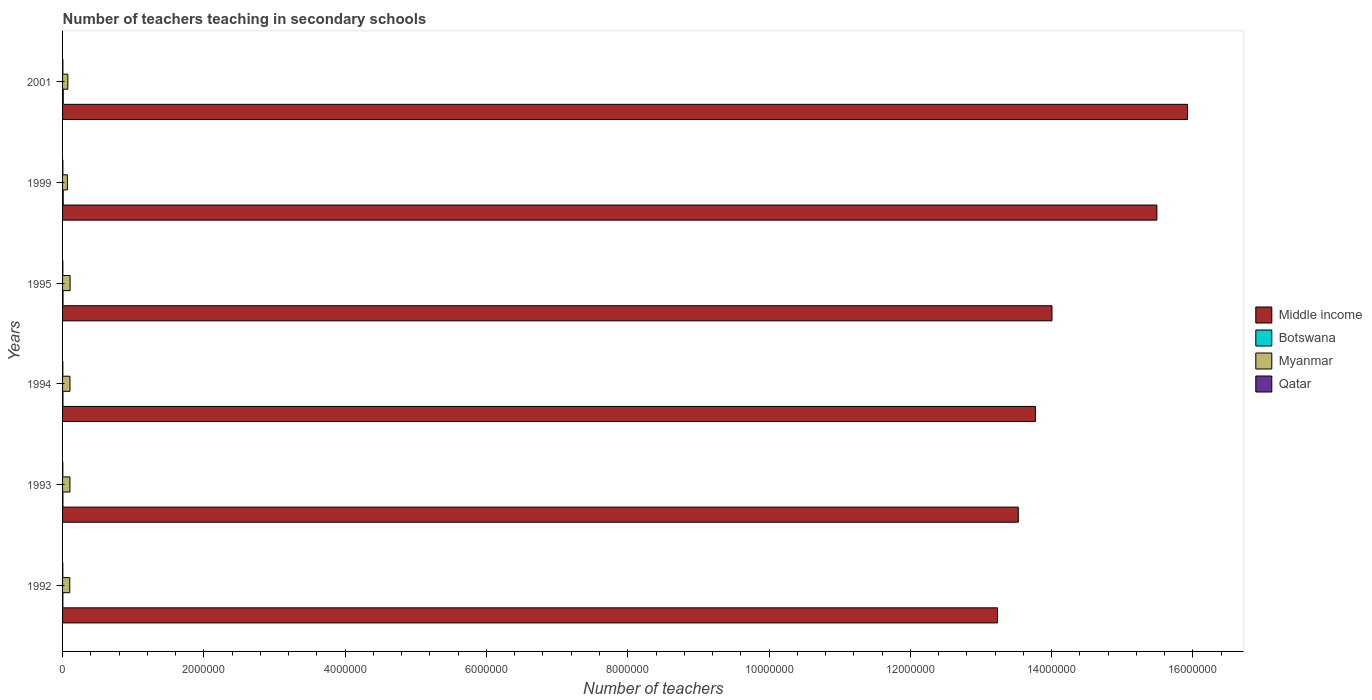Are the number of bars per tick equal to the number of legend labels?
Provide a succinct answer. Yes. Are the number of bars on each tick of the Y-axis equal?
Offer a very short reply. Yes. How many bars are there on the 1st tick from the bottom?
Keep it short and to the point. 4. What is the number of teachers teaching in secondary schools in Myanmar in 1995?
Your response must be concise. 1.07e+05. Across all years, what is the maximum number of teachers teaching in secondary schools in Qatar?
Make the answer very short. 4516. Across all years, what is the minimum number of teachers teaching in secondary schools in Qatar?
Your answer should be compact. 3724. What is the total number of teachers teaching in secondary schools in Middle income in the graph?
Your answer should be compact. 8.60e+07. What is the difference between the number of teachers teaching in secondary schools in Qatar in 1995 and that in 2001?
Keep it short and to the point. -658. What is the difference between the number of teachers teaching in secondary schools in Qatar in 1992 and the number of teachers teaching in secondary schools in Middle income in 1995?
Your answer should be compact. -1.40e+07. What is the average number of teachers teaching in secondary schools in Middle income per year?
Provide a succinct answer. 1.43e+07. In the year 1999, what is the difference between the number of teachers teaching in secondary schools in Middle income and number of teachers teaching in secondary schools in Qatar?
Your answer should be very brief. 1.55e+07. In how many years, is the number of teachers teaching in secondary schools in Myanmar greater than 14000000 ?
Your response must be concise. 0. What is the ratio of the number of teachers teaching in secondary schools in Myanmar in 1995 to that in 2001?
Make the answer very short. 1.43. Is the difference between the number of teachers teaching in secondary schools in Middle income in 1992 and 1999 greater than the difference between the number of teachers teaching in secondary schools in Qatar in 1992 and 1999?
Keep it short and to the point. No. What is the difference between the highest and the second highest number of teachers teaching in secondary schools in Qatar?
Keep it short and to the point. 146. What is the difference between the highest and the lowest number of teachers teaching in secondary schools in Middle income?
Your response must be concise. 2.69e+06. In how many years, is the number of teachers teaching in secondary schools in Middle income greater than the average number of teachers teaching in secondary schools in Middle income taken over all years?
Give a very brief answer. 2. Is it the case that in every year, the sum of the number of teachers teaching in secondary schools in Botswana and number of teachers teaching in secondary schools in Myanmar is greater than the sum of number of teachers teaching in secondary schools in Middle income and number of teachers teaching in secondary schools in Qatar?
Make the answer very short. Yes. What does the 1st bar from the top in 1994 represents?
Offer a very short reply. Qatar. What does the 4th bar from the bottom in 1995 represents?
Provide a short and direct response. Qatar. Is it the case that in every year, the sum of the number of teachers teaching in secondary schools in Myanmar and number of teachers teaching in secondary schools in Botswana is greater than the number of teachers teaching in secondary schools in Qatar?
Give a very brief answer. Yes. What is the difference between two consecutive major ticks on the X-axis?
Your response must be concise. 2.00e+06. Does the graph contain any zero values?
Keep it short and to the point. No. Does the graph contain grids?
Offer a terse response. No. What is the title of the graph?
Your answer should be very brief. Number of teachers teaching in secondary schools. Does "Philippines" appear as one of the legend labels in the graph?
Provide a succinct answer. No. What is the label or title of the X-axis?
Your answer should be very brief. Number of teachers. What is the Number of teachers of Middle income in 1992?
Provide a succinct answer. 1.32e+07. What is the Number of teachers of Botswana in 1992?
Provide a short and direct response. 4467. What is the Number of teachers of Myanmar in 1992?
Your answer should be compact. 1.02e+05. What is the Number of teachers of Qatar in 1992?
Offer a very short reply. 3724. What is the Number of teachers of Middle income in 1993?
Your answer should be very brief. 1.35e+07. What is the Number of teachers of Botswana in 1993?
Ensure brevity in your answer.  5084. What is the Number of teachers in Myanmar in 1993?
Your response must be concise. 1.04e+05. What is the Number of teachers of Qatar in 1993?
Provide a short and direct response. 3728. What is the Number of teachers in Middle income in 1994?
Ensure brevity in your answer.  1.38e+07. What is the Number of teachers in Botswana in 1994?
Keep it short and to the point. 5475. What is the Number of teachers in Myanmar in 1994?
Provide a short and direct response. 1.05e+05. What is the Number of teachers of Qatar in 1994?
Make the answer very short. 3823. What is the Number of teachers in Middle income in 1995?
Give a very brief answer. 1.40e+07. What is the Number of teachers in Botswana in 1995?
Offer a terse response. 6670. What is the Number of teachers in Myanmar in 1995?
Offer a terse response. 1.07e+05. What is the Number of teachers in Qatar in 1995?
Make the answer very short. 3858. What is the Number of teachers of Middle income in 1999?
Give a very brief answer. 1.55e+07. What is the Number of teachers of Botswana in 1999?
Provide a short and direct response. 8976. What is the Number of teachers of Myanmar in 1999?
Your answer should be compact. 6.84e+04. What is the Number of teachers of Qatar in 1999?
Provide a short and direct response. 4370. What is the Number of teachers in Middle income in 2001?
Keep it short and to the point. 1.59e+07. What is the Number of teachers in Botswana in 2001?
Offer a very short reply. 9784. What is the Number of teachers of Myanmar in 2001?
Your response must be concise. 7.47e+04. What is the Number of teachers in Qatar in 2001?
Your answer should be very brief. 4516. Across all years, what is the maximum Number of teachers in Middle income?
Offer a very short reply. 1.59e+07. Across all years, what is the maximum Number of teachers of Botswana?
Your response must be concise. 9784. Across all years, what is the maximum Number of teachers in Myanmar?
Ensure brevity in your answer.  1.07e+05. Across all years, what is the maximum Number of teachers of Qatar?
Provide a succinct answer. 4516. Across all years, what is the minimum Number of teachers in Middle income?
Offer a very short reply. 1.32e+07. Across all years, what is the minimum Number of teachers of Botswana?
Offer a very short reply. 4467. Across all years, what is the minimum Number of teachers in Myanmar?
Your answer should be very brief. 6.84e+04. Across all years, what is the minimum Number of teachers in Qatar?
Your answer should be very brief. 3724. What is the total Number of teachers of Middle income in the graph?
Keep it short and to the point. 8.60e+07. What is the total Number of teachers in Botswana in the graph?
Offer a terse response. 4.05e+04. What is the total Number of teachers in Myanmar in the graph?
Offer a very short reply. 5.61e+05. What is the total Number of teachers in Qatar in the graph?
Provide a succinct answer. 2.40e+04. What is the difference between the Number of teachers in Middle income in 1992 and that in 1993?
Provide a succinct answer. -2.94e+05. What is the difference between the Number of teachers of Botswana in 1992 and that in 1993?
Your response must be concise. -617. What is the difference between the Number of teachers in Myanmar in 1992 and that in 1993?
Provide a succinct answer. -2528. What is the difference between the Number of teachers in Middle income in 1992 and that in 1994?
Your answer should be very brief. -5.36e+05. What is the difference between the Number of teachers of Botswana in 1992 and that in 1994?
Your answer should be compact. -1008. What is the difference between the Number of teachers of Myanmar in 1992 and that in 1994?
Your response must be concise. -2866. What is the difference between the Number of teachers of Qatar in 1992 and that in 1994?
Ensure brevity in your answer.  -99. What is the difference between the Number of teachers in Middle income in 1992 and that in 1995?
Your answer should be compact. -7.71e+05. What is the difference between the Number of teachers in Botswana in 1992 and that in 1995?
Keep it short and to the point. -2203. What is the difference between the Number of teachers of Myanmar in 1992 and that in 1995?
Offer a terse response. -4641. What is the difference between the Number of teachers of Qatar in 1992 and that in 1995?
Your answer should be very brief. -134. What is the difference between the Number of teachers of Middle income in 1992 and that in 1999?
Your answer should be very brief. -2.26e+06. What is the difference between the Number of teachers in Botswana in 1992 and that in 1999?
Offer a terse response. -4509. What is the difference between the Number of teachers of Myanmar in 1992 and that in 1999?
Keep it short and to the point. 3.35e+04. What is the difference between the Number of teachers of Qatar in 1992 and that in 1999?
Provide a short and direct response. -646. What is the difference between the Number of teachers of Middle income in 1992 and that in 2001?
Make the answer very short. -2.69e+06. What is the difference between the Number of teachers of Botswana in 1992 and that in 2001?
Offer a terse response. -5317. What is the difference between the Number of teachers in Myanmar in 1992 and that in 2001?
Provide a short and direct response. 2.72e+04. What is the difference between the Number of teachers of Qatar in 1992 and that in 2001?
Provide a succinct answer. -792. What is the difference between the Number of teachers of Middle income in 1993 and that in 1994?
Keep it short and to the point. -2.42e+05. What is the difference between the Number of teachers in Botswana in 1993 and that in 1994?
Offer a very short reply. -391. What is the difference between the Number of teachers in Myanmar in 1993 and that in 1994?
Provide a succinct answer. -338. What is the difference between the Number of teachers of Qatar in 1993 and that in 1994?
Offer a terse response. -95. What is the difference between the Number of teachers of Middle income in 1993 and that in 1995?
Offer a terse response. -4.77e+05. What is the difference between the Number of teachers of Botswana in 1993 and that in 1995?
Offer a terse response. -1586. What is the difference between the Number of teachers of Myanmar in 1993 and that in 1995?
Give a very brief answer. -2113. What is the difference between the Number of teachers of Qatar in 1993 and that in 1995?
Offer a very short reply. -130. What is the difference between the Number of teachers in Middle income in 1993 and that in 1999?
Make the answer very short. -1.96e+06. What is the difference between the Number of teachers of Botswana in 1993 and that in 1999?
Your answer should be very brief. -3892. What is the difference between the Number of teachers in Myanmar in 1993 and that in 1999?
Ensure brevity in your answer.  3.60e+04. What is the difference between the Number of teachers in Qatar in 1993 and that in 1999?
Keep it short and to the point. -642. What is the difference between the Number of teachers of Middle income in 1993 and that in 2001?
Make the answer very short. -2.40e+06. What is the difference between the Number of teachers of Botswana in 1993 and that in 2001?
Offer a terse response. -4700. What is the difference between the Number of teachers in Myanmar in 1993 and that in 2001?
Give a very brief answer. 2.97e+04. What is the difference between the Number of teachers of Qatar in 1993 and that in 2001?
Your response must be concise. -788. What is the difference between the Number of teachers in Middle income in 1994 and that in 1995?
Keep it short and to the point. -2.35e+05. What is the difference between the Number of teachers in Botswana in 1994 and that in 1995?
Provide a succinct answer. -1195. What is the difference between the Number of teachers in Myanmar in 1994 and that in 1995?
Your answer should be compact. -1775. What is the difference between the Number of teachers in Qatar in 1994 and that in 1995?
Offer a very short reply. -35. What is the difference between the Number of teachers of Middle income in 1994 and that in 1999?
Make the answer very short. -1.72e+06. What is the difference between the Number of teachers in Botswana in 1994 and that in 1999?
Provide a succinct answer. -3501. What is the difference between the Number of teachers of Myanmar in 1994 and that in 1999?
Ensure brevity in your answer.  3.64e+04. What is the difference between the Number of teachers of Qatar in 1994 and that in 1999?
Make the answer very short. -547. What is the difference between the Number of teachers of Middle income in 1994 and that in 2001?
Make the answer very short. -2.15e+06. What is the difference between the Number of teachers of Botswana in 1994 and that in 2001?
Your response must be concise. -4309. What is the difference between the Number of teachers in Myanmar in 1994 and that in 2001?
Make the answer very short. 3.00e+04. What is the difference between the Number of teachers in Qatar in 1994 and that in 2001?
Your response must be concise. -693. What is the difference between the Number of teachers in Middle income in 1995 and that in 1999?
Give a very brief answer. -1.49e+06. What is the difference between the Number of teachers of Botswana in 1995 and that in 1999?
Provide a short and direct response. -2306. What is the difference between the Number of teachers in Myanmar in 1995 and that in 1999?
Provide a succinct answer. 3.82e+04. What is the difference between the Number of teachers of Qatar in 1995 and that in 1999?
Your answer should be very brief. -512. What is the difference between the Number of teachers in Middle income in 1995 and that in 2001?
Offer a terse response. -1.92e+06. What is the difference between the Number of teachers in Botswana in 1995 and that in 2001?
Make the answer very short. -3114. What is the difference between the Number of teachers in Myanmar in 1995 and that in 2001?
Ensure brevity in your answer.  3.18e+04. What is the difference between the Number of teachers in Qatar in 1995 and that in 2001?
Offer a very short reply. -658. What is the difference between the Number of teachers in Middle income in 1999 and that in 2001?
Your answer should be compact. -4.34e+05. What is the difference between the Number of teachers in Botswana in 1999 and that in 2001?
Offer a very short reply. -808. What is the difference between the Number of teachers in Myanmar in 1999 and that in 2001?
Keep it short and to the point. -6338. What is the difference between the Number of teachers of Qatar in 1999 and that in 2001?
Offer a very short reply. -146. What is the difference between the Number of teachers in Middle income in 1992 and the Number of teachers in Botswana in 1993?
Give a very brief answer. 1.32e+07. What is the difference between the Number of teachers in Middle income in 1992 and the Number of teachers in Myanmar in 1993?
Offer a very short reply. 1.31e+07. What is the difference between the Number of teachers in Middle income in 1992 and the Number of teachers in Qatar in 1993?
Give a very brief answer. 1.32e+07. What is the difference between the Number of teachers of Botswana in 1992 and the Number of teachers of Myanmar in 1993?
Provide a short and direct response. -9.99e+04. What is the difference between the Number of teachers in Botswana in 1992 and the Number of teachers in Qatar in 1993?
Your answer should be very brief. 739. What is the difference between the Number of teachers in Myanmar in 1992 and the Number of teachers in Qatar in 1993?
Your response must be concise. 9.81e+04. What is the difference between the Number of teachers in Middle income in 1992 and the Number of teachers in Botswana in 1994?
Give a very brief answer. 1.32e+07. What is the difference between the Number of teachers in Middle income in 1992 and the Number of teachers in Myanmar in 1994?
Keep it short and to the point. 1.31e+07. What is the difference between the Number of teachers of Middle income in 1992 and the Number of teachers of Qatar in 1994?
Your response must be concise. 1.32e+07. What is the difference between the Number of teachers of Botswana in 1992 and the Number of teachers of Myanmar in 1994?
Make the answer very short. -1.00e+05. What is the difference between the Number of teachers of Botswana in 1992 and the Number of teachers of Qatar in 1994?
Your response must be concise. 644. What is the difference between the Number of teachers in Myanmar in 1992 and the Number of teachers in Qatar in 1994?
Provide a succinct answer. 9.81e+04. What is the difference between the Number of teachers of Middle income in 1992 and the Number of teachers of Botswana in 1995?
Offer a terse response. 1.32e+07. What is the difference between the Number of teachers in Middle income in 1992 and the Number of teachers in Myanmar in 1995?
Your response must be concise. 1.31e+07. What is the difference between the Number of teachers in Middle income in 1992 and the Number of teachers in Qatar in 1995?
Provide a short and direct response. 1.32e+07. What is the difference between the Number of teachers in Botswana in 1992 and the Number of teachers in Myanmar in 1995?
Your answer should be compact. -1.02e+05. What is the difference between the Number of teachers of Botswana in 1992 and the Number of teachers of Qatar in 1995?
Keep it short and to the point. 609. What is the difference between the Number of teachers in Myanmar in 1992 and the Number of teachers in Qatar in 1995?
Your answer should be compact. 9.80e+04. What is the difference between the Number of teachers in Middle income in 1992 and the Number of teachers in Botswana in 1999?
Your response must be concise. 1.32e+07. What is the difference between the Number of teachers in Middle income in 1992 and the Number of teachers in Myanmar in 1999?
Keep it short and to the point. 1.32e+07. What is the difference between the Number of teachers in Middle income in 1992 and the Number of teachers in Qatar in 1999?
Offer a very short reply. 1.32e+07. What is the difference between the Number of teachers in Botswana in 1992 and the Number of teachers in Myanmar in 1999?
Offer a terse response. -6.39e+04. What is the difference between the Number of teachers of Botswana in 1992 and the Number of teachers of Qatar in 1999?
Provide a succinct answer. 97. What is the difference between the Number of teachers of Myanmar in 1992 and the Number of teachers of Qatar in 1999?
Provide a succinct answer. 9.75e+04. What is the difference between the Number of teachers in Middle income in 1992 and the Number of teachers in Botswana in 2001?
Keep it short and to the point. 1.32e+07. What is the difference between the Number of teachers in Middle income in 1992 and the Number of teachers in Myanmar in 2001?
Ensure brevity in your answer.  1.32e+07. What is the difference between the Number of teachers in Middle income in 1992 and the Number of teachers in Qatar in 2001?
Offer a very short reply. 1.32e+07. What is the difference between the Number of teachers of Botswana in 1992 and the Number of teachers of Myanmar in 2001?
Ensure brevity in your answer.  -7.02e+04. What is the difference between the Number of teachers in Botswana in 1992 and the Number of teachers in Qatar in 2001?
Your response must be concise. -49. What is the difference between the Number of teachers of Myanmar in 1992 and the Number of teachers of Qatar in 2001?
Your answer should be compact. 9.74e+04. What is the difference between the Number of teachers in Middle income in 1993 and the Number of teachers in Botswana in 1994?
Ensure brevity in your answer.  1.35e+07. What is the difference between the Number of teachers of Middle income in 1993 and the Number of teachers of Myanmar in 1994?
Keep it short and to the point. 1.34e+07. What is the difference between the Number of teachers in Middle income in 1993 and the Number of teachers in Qatar in 1994?
Provide a short and direct response. 1.35e+07. What is the difference between the Number of teachers of Botswana in 1993 and the Number of teachers of Myanmar in 1994?
Your response must be concise. -9.97e+04. What is the difference between the Number of teachers in Botswana in 1993 and the Number of teachers in Qatar in 1994?
Ensure brevity in your answer.  1261. What is the difference between the Number of teachers in Myanmar in 1993 and the Number of teachers in Qatar in 1994?
Offer a very short reply. 1.01e+05. What is the difference between the Number of teachers of Middle income in 1993 and the Number of teachers of Botswana in 1995?
Offer a very short reply. 1.35e+07. What is the difference between the Number of teachers of Middle income in 1993 and the Number of teachers of Myanmar in 1995?
Your answer should be compact. 1.34e+07. What is the difference between the Number of teachers of Middle income in 1993 and the Number of teachers of Qatar in 1995?
Offer a very short reply. 1.35e+07. What is the difference between the Number of teachers of Botswana in 1993 and the Number of teachers of Myanmar in 1995?
Ensure brevity in your answer.  -1.01e+05. What is the difference between the Number of teachers in Botswana in 1993 and the Number of teachers in Qatar in 1995?
Your response must be concise. 1226. What is the difference between the Number of teachers in Myanmar in 1993 and the Number of teachers in Qatar in 1995?
Offer a very short reply. 1.01e+05. What is the difference between the Number of teachers of Middle income in 1993 and the Number of teachers of Botswana in 1999?
Your answer should be compact. 1.35e+07. What is the difference between the Number of teachers in Middle income in 1993 and the Number of teachers in Myanmar in 1999?
Give a very brief answer. 1.35e+07. What is the difference between the Number of teachers in Middle income in 1993 and the Number of teachers in Qatar in 1999?
Ensure brevity in your answer.  1.35e+07. What is the difference between the Number of teachers of Botswana in 1993 and the Number of teachers of Myanmar in 1999?
Provide a short and direct response. -6.33e+04. What is the difference between the Number of teachers in Botswana in 1993 and the Number of teachers in Qatar in 1999?
Give a very brief answer. 714. What is the difference between the Number of teachers of Myanmar in 1993 and the Number of teachers of Qatar in 1999?
Ensure brevity in your answer.  1.00e+05. What is the difference between the Number of teachers in Middle income in 1993 and the Number of teachers in Botswana in 2001?
Your answer should be compact. 1.35e+07. What is the difference between the Number of teachers in Middle income in 1993 and the Number of teachers in Myanmar in 2001?
Make the answer very short. 1.35e+07. What is the difference between the Number of teachers in Middle income in 1993 and the Number of teachers in Qatar in 2001?
Provide a short and direct response. 1.35e+07. What is the difference between the Number of teachers in Botswana in 1993 and the Number of teachers in Myanmar in 2001?
Give a very brief answer. -6.96e+04. What is the difference between the Number of teachers of Botswana in 1993 and the Number of teachers of Qatar in 2001?
Ensure brevity in your answer.  568. What is the difference between the Number of teachers in Myanmar in 1993 and the Number of teachers in Qatar in 2001?
Offer a terse response. 9.99e+04. What is the difference between the Number of teachers in Middle income in 1994 and the Number of teachers in Botswana in 1995?
Give a very brief answer. 1.38e+07. What is the difference between the Number of teachers of Middle income in 1994 and the Number of teachers of Myanmar in 1995?
Your answer should be compact. 1.37e+07. What is the difference between the Number of teachers in Middle income in 1994 and the Number of teachers in Qatar in 1995?
Provide a short and direct response. 1.38e+07. What is the difference between the Number of teachers in Botswana in 1994 and the Number of teachers in Myanmar in 1995?
Your answer should be compact. -1.01e+05. What is the difference between the Number of teachers of Botswana in 1994 and the Number of teachers of Qatar in 1995?
Provide a succinct answer. 1617. What is the difference between the Number of teachers of Myanmar in 1994 and the Number of teachers of Qatar in 1995?
Give a very brief answer. 1.01e+05. What is the difference between the Number of teachers in Middle income in 1994 and the Number of teachers in Botswana in 1999?
Your response must be concise. 1.38e+07. What is the difference between the Number of teachers of Middle income in 1994 and the Number of teachers of Myanmar in 1999?
Keep it short and to the point. 1.37e+07. What is the difference between the Number of teachers in Middle income in 1994 and the Number of teachers in Qatar in 1999?
Offer a very short reply. 1.38e+07. What is the difference between the Number of teachers in Botswana in 1994 and the Number of teachers in Myanmar in 1999?
Your answer should be compact. -6.29e+04. What is the difference between the Number of teachers in Botswana in 1994 and the Number of teachers in Qatar in 1999?
Ensure brevity in your answer.  1105. What is the difference between the Number of teachers of Myanmar in 1994 and the Number of teachers of Qatar in 1999?
Offer a very short reply. 1.00e+05. What is the difference between the Number of teachers in Middle income in 1994 and the Number of teachers in Botswana in 2001?
Your response must be concise. 1.38e+07. What is the difference between the Number of teachers in Middle income in 1994 and the Number of teachers in Myanmar in 2001?
Provide a short and direct response. 1.37e+07. What is the difference between the Number of teachers of Middle income in 1994 and the Number of teachers of Qatar in 2001?
Provide a short and direct response. 1.38e+07. What is the difference between the Number of teachers in Botswana in 1994 and the Number of teachers in Myanmar in 2001?
Keep it short and to the point. -6.92e+04. What is the difference between the Number of teachers in Botswana in 1994 and the Number of teachers in Qatar in 2001?
Keep it short and to the point. 959. What is the difference between the Number of teachers in Myanmar in 1994 and the Number of teachers in Qatar in 2001?
Your response must be concise. 1.00e+05. What is the difference between the Number of teachers in Middle income in 1995 and the Number of teachers in Botswana in 1999?
Your answer should be very brief. 1.40e+07. What is the difference between the Number of teachers of Middle income in 1995 and the Number of teachers of Myanmar in 1999?
Your answer should be compact. 1.39e+07. What is the difference between the Number of teachers of Middle income in 1995 and the Number of teachers of Qatar in 1999?
Keep it short and to the point. 1.40e+07. What is the difference between the Number of teachers of Botswana in 1995 and the Number of teachers of Myanmar in 1999?
Keep it short and to the point. -6.17e+04. What is the difference between the Number of teachers in Botswana in 1995 and the Number of teachers in Qatar in 1999?
Your response must be concise. 2300. What is the difference between the Number of teachers of Myanmar in 1995 and the Number of teachers of Qatar in 1999?
Ensure brevity in your answer.  1.02e+05. What is the difference between the Number of teachers of Middle income in 1995 and the Number of teachers of Botswana in 2001?
Offer a terse response. 1.40e+07. What is the difference between the Number of teachers in Middle income in 1995 and the Number of teachers in Myanmar in 2001?
Your answer should be compact. 1.39e+07. What is the difference between the Number of teachers in Middle income in 1995 and the Number of teachers in Qatar in 2001?
Your answer should be very brief. 1.40e+07. What is the difference between the Number of teachers of Botswana in 1995 and the Number of teachers of Myanmar in 2001?
Give a very brief answer. -6.80e+04. What is the difference between the Number of teachers in Botswana in 1995 and the Number of teachers in Qatar in 2001?
Offer a terse response. 2154. What is the difference between the Number of teachers in Myanmar in 1995 and the Number of teachers in Qatar in 2001?
Provide a succinct answer. 1.02e+05. What is the difference between the Number of teachers in Middle income in 1999 and the Number of teachers in Botswana in 2001?
Give a very brief answer. 1.55e+07. What is the difference between the Number of teachers of Middle income in 1999 and the Number of teachers of Myanmar in 2001?
Provide a succinct answer. 1.54e+07. What is the difference between the Number of teachers in Middle income in 1999 and the Number of teachers in Qatar in 2001?
Offer a very short reply. 1.55e+07. What is the difference between the Number of teachers of Botswana in 1999 and the Number of teachers of Myanmar in 2001?
Offer a very short reply. -6.57e+04. What is the difference between the Number of teachers of Botswana in 1999 and the Number of teachers of Qatar in 2001?
Your answer should be very brief. 4460. What is the difference between the Number of teachers in Myanmar in 1999 and the Number of teachers in Qatar in 2001?
Your response must be concise. 6.38e+04. What is the average Number of teachers of Middle income per year?
Make the answer very short. 1.43e+07. What is the average Number of teachers of Botswana per year?
Your answer should be compact. 6742.67. What is the average Number of teachers in Myanmar per year?
Your response must be concise. 9.34e+04. What is the average Number of teachers of Qatar per year?
Offer a terse response. 4003.17. In the year 1992, what is the difference between the Number of teachers in Middle income and Number of teachers in Botswana?
Make the answer very short. 1.32e+07. In the year 1992, what is the difference between the Number of teachers in Middle income and Number of teachers in Myanmar?
Your answer should be very brief. 1.31e+07. In the year 1992, what is the difference between the Number of teachers in Middle income and Number of teachers in Qatar?
Offer a terse response. 1.32e+07. In the year 1992, what is the difference between the Number of teachers in Botswana and Number of teachers in Myanmar?
Keep it short and to the point. -9.74e+04. In the year 1992, what is the difference between the Number of teachers of Botswana and Number of teachers of Qatar?
Your response must be concise. 743. In the year 1992, what is the difference between the Number of teachers in Myanmar and Number of teachers in Qatar?
Give a very brief answer. 9.82e+04. In the year 1993, what is the difference between the Number of teachers in Middle income and Number of teachers in Botswana?
Your answer should be very brief. 1.35e+07. In the year 1993, what is the difference between the Number of teachers of Middle income and Number of teachers of Myanmar?
Make the answer very short. 1.34e+07. In the year 1993, what is the difference between the Number of teachers in Middle income and Number of teachers in Qatar?
Your response must be concise. 1.35e+07. In the year 1993, what is the difference between the Number of teachers in Botswana and Number of teachers in Myanmar?
Make the answer very short. -9.93e+04. In the year 1993, what is the difference between the Number of teachers of Botswana and Number of teachers of Qatar?
Your response must be concise. 1356. In the year 1993, what is the difference between the Number of teachers in Myanmar and Number of teachers in Qatar?
Your answer should be compact. 1.01e+05. In the year 1994, what is the difference between the Number of teachers of Middle income and Number of teachers of Botswana?
Give a very brief answer. 1.38e+07. In the year 1994, what is the difference between the Number of teachers of Middle income and Number of teachers of Myanmar?
Keep it short and to the point. 1.37e+07. In the year 1994, what is the difference between the Number of teachers in Middle income and Number of teachers in Qatar?
Provide a succinct answer. 1.38e+07. In the year 1994, what is the difference between the Number of teachers of Botswana and Number of teachers of Myanmar?
Make the answer very short. -9.93e+04. In the year 1994, what is the difference between the Number of teachers in Botswana and Number of teachers in Qatar?
Your answer should be compact. 1652. In the year 1994, what is the difference between the Number of teachers of Myanmar and Number of teachers of Qatar?
Provide a succinct answer. 1.01e+05. In the year 1995, what is the difference between the Number of teachers in Middle income and Number of teachers in Botswana?
Your answer should be compact. 1.40e+07. In the year 1995, what is the difference between the Number of teachers of Middle income and Number of teachers of Myanmar?
Offer a terse response. 1.39e+07. In the year 1995, what is the difference between the Number of teachers in Middle income and Number of teachers in Qatar?
Your answer should be very brief. 1.40e+07. In the year 1995, what is the difference between the Number of teachers in Botswana and Number of teachers in Myanmar?
Offer a terse response. -9.98e+04. In the year 1995, what is the difference between the Number of teachers in Botswana and Number of teachers in Qatar?
Your answer should be compact. 2812. In the year 1995, what is the difference between the Number of teachers in Myanmar and Number of teachers in Qatar?
Make the answer very short. 1.03e+05. In the year 1999, what is the difference between the Number of teachers of Middle income and Number of teachers of Botswana?
Keep it short and to the point. 1.55e+07. In the year 1999, what is the difference between the Number of teachers in Middle income and Number of teachers in Myanmar?
Ensure brevity in your answer.  1.54e+07. In the year 1999, what is the difference between the Number of teachers in Middle income and Number of teachers in Qatar?
Your response must be concise. 1.55e+07. In the year 1999, what is the difference between the Number of teachers in Botswana and Number of teachers in Myanmar?
Make the answer very short. -5.94e+04. In the year 1999, what is the difference between the Number of teachers in Botswana and Number of teachers in Qatar?
Offer a very short reply. 4606. In the year 1999, what is the difference between the Number of teachers in Myanmar and Number of teachers in Qatar?
Your answer should be very brief. 6.40e+04. In the year 2001, what is the difference between the Number of teachers of Middle income and Number of teachers of Botswana?
Offer a terse response. 1.59e+07. In the year 2001, what is the difference between the Number of teachers of Middle income and Number of teachers of Myanmar?
Provide a short and direct response. 1.58e+07. In the year 2001, what is the difference between the Number of teachers in Middle income and Number of teachers in Qatar?
Offer a very short reply. 1.59e+07. In the year 2001, what is the difference between the Number of teachers of Botswana and Number of teachers of Myanmar?
Offer a very short reply. -6.49e+04. In the year 2001, what is the difference between the Number of teachers in Botswana and Number of teachers in Qatar?
Give a very brief answer. 5268. In the year 2001, what is the difference between the Number of teachers in Myanmar and Number of teachers in Qatar?
Ensure brevity in your answer.  7.02e+04. What is the ratio of the Number of teachers of Middle income in 1992 to that in 1993?
Give a very brief answer. 0.98. What is the ratio of the Number of teachers in Botswana in 1992 to that in 1993?
Ensure brevity in your answer.  0.88. What is the ratio of the Number of teachers in Myanmar in 1992 to that in 1993?
Make the answer very short. 0.98. What is the ratio of the Number of teachers of Qatar in 1992 to that in 1993?
Ensure brevity in your answer.  1. What is the ratio of the Number of teachers in Middle income in 1992 to that in 1994?
Offer a very short reply. 0.96. What is the ratio of the Number of teachers of Botswana in 1992 to that in 1994?
Your answer should be compact. 0.82. What is the ratio of the Number of teachers of Myanmar in 1992 to that in 1994?
Give a very brief answer. 0.97. What is the ratio of the Number of teachers of Qatar in 1992 to that in 1994?
Give a very brief answer. 0.97. What is the ratio of the Number of teachers of Middle income in 1992 to that in 1995?
Offer a very short reply. 0.94. What is the ratio of the Number of teachers in Botswana in 1992 to that in 1995?
Your response must be concise. 0.67. What is the ratio of the Number of teachers of Myanmar in 1992 to that in 1995?
Ensure brevity in your answer.  0.96. What is the ratio of the Number of teachers in Qatar in 1992 to that in 1995?
Your answer should be very brief. 0.97. What is the ratio of the Number of teachers in Middle income in 1992 to that in 1999?
Provide a short and direct response. 0.85. What is the ratio of the Number of teachers of Botswana in 1992 to that in 1999?
Provide a succinct answer. 0.5. What is the ratio of the Number of teachers in Myanmar in 1992 to that in 1999?
Make the answer very short. 1.49. What is the ratio of the Number of teachers in Qatar in 1992 to that in 1999?
Your response must be concise. 0.85. What is the ratio of the Number of teachers of Middle income in 1992 to that in 2001?
Give a very brief answer. 0.83. What is the ratio of the Number of teachers in Botswana in 1992 to that in 2001?
Make the answer very short. 0.46. What is the ratio of the Number of teachers of Myanmar in 1992 to that in 2001?
Offer a terse response. 1.36. What is the ratio of the Number of teachers of Qatar in 1992 to that in 2001?
Provide a succinct answer. 0.82. What is the ratio of the Number of teachers of Middle income in 1993 to that in 1994?
Offer a terse response. 0.98. What is the ratio of the Number of teachers of Botswana in 1993 to that in 1994?
Make the answer very short. 0.93. What is the ratio of the Number of teachers of Myanmar in 1993 to that in 1994?
Offer a very short reply. 1. What is the ratio of the Number of teachers in Qatar in 1993 to that in 1994?
Your answer should be compact. 0.98. What is the ratio of the Number of teachers in Middle income in 1993 to that in 1995?
Make the answer very short. 0.97. What is the ratio of the Number of teachers in Botswana in 1993 to that in 1995?
Ensure brevity in your answer.  0.76. What is the ratio of the Number of teachers of Myanmar in 1993 to that in 1995?
Offer a terse response. 0.98. What is the ratio of the Number of teachers in Qatar in 1993 to that in 1995?
Your answer should be very brief. 0.97. What is the ratio of the Number of teachers in Middle income in 1993 to that in 1999?
Provide a short and direct response. 0.87. What is the ratio of the Number of teachers in Botswana in 1993 to that in 1999?
Make the answer very short. 0.57. What is the ratio of the Number of teachers of Myanmar in 1993 to that in 1999?
Ensure brevity in your answer.  1.53. What is the ratio of the Number of teachers in Qatar in 1993 to that in 1999?
Your answer should be compact. 0.85. What is the ratio of the Number of teachers in Middle income in 1993 to that in 2001?
Make the answer very short. 0.85. What is the ratio of the Number of teachers in Botswana in 1993 to that in 2001?
Offer a terse response. 0.52. What is the ratio of the Number of teachers in Myanmar in 1993 to that in 2001?
Offer a terse response. 1.4. What is the ratio of the Number of teachers of Qatar in 1993 to that in 2001?
Your response must be concise. 0.83. What is the ratio of the Number of teachers in Middle income in 1994 to that in 1995?
Provide a succinct answer. 0.98. What is the ratio of the Number of teachers in Botswana in 1994 to that in 1995?
Your answer should be very brief. 0.82. What is the ratio of the Number of teachers of Myanmar in 1994 to that in 1995?
Make the answer very short. 0.98. What is the ratio of the Number of teachers of Qatar in 1994 to that in 1995?
Your answer should be very brief. 0.99. What is the ratio of the Number of teachers in Middle income in 1994 to that in 1999?
Keep it short and to the point. 0.89. What is the ratio of the Number of teachers of Botswana in 1994 to that in 1999?
Keep it short and to the point. 0.61. What is the ratio of the Number of teachers of Myanmar in 1994 to that in 1999?
Provide a short and direct response. 1.53. What is the ratio of the Number of teachers of Qatar in 1994 to that in 1999?
Keep it short and to the point. 0.87. What is the ratio of the Number of teachers of Middle income in 1994 to that in 2001?
Provide a short and direct response. 0.86. What is the ratio of the Number of teachers of Botswana in 1994 to that in 2001?
Provide a succinct answer. 0.56. What is the ratio of the Number of teachers in Myanmar in 1994 to that in 2001?
Provide a succinct answer. 1.4. What is the ratio of the Number of teachers of Qatar in 1994 to that in 2001?
Your answer should be very brief. 0.85. What is the ratio of the Number of teachers of Middle income in 1995 to that in 1999?
Provide a succinct answer. 0.9. What is the ratio of the Number of teachers of Botswana in 1995 to that in 1999?
Your answer should be compact. 0.74. What is the ratio of the Number of teachers of Myanmar in 1995 to that in 1999?
Give a very brief answer. 1.56. What is the ratio of the Number of teachers of Qatar in 1995 to that in 1999?
Your answer should be compact. 0.88. What is the ratio of the Number of teachers in Middle income in 1995 to that in 2001?
Keep it short and to the point. 0.88. What is the ratio of the Number of teachers in Botswana in 1995 to that in 2001?
Make the answer very short. 0.68. What is the ratio of the Number of teachers of Myanmar in 1995 to that in 2001?
Provide a short and direct response. 1.43. What is the ratio of the Number of teachers of Qatar in 1995 to that in 2001?
Provide a succinct answer. 0.85. What is the ratio of the Number of teachers in Middle income in 1999 to that in 2001?
Keep it short and to the point. 0.97. What is the ratio of the Number of teachers of Botswana in 1999 to that in 2001?
Ensure brevity in your answer.  0.92. What is the ratio of the Number of teachers in Myanmar in 1999 to that in 2001?
Offer a very short reply. 0.92. What is the ratio of the Number of teachers of Qatar in 1999 to that in 2001?
Ensure brevity in your answer.  0.97. What is the difference between the highest and the second highest Number of teachers in Middle income?
Offer a terse response. 4.34e+05. What is the difference between the highest and the second highest Number of teachers in Botswana?
Give a very brief answer. 808. What is the difference between the highest and the second highest Number of teachers in Myanmar?
Keep it short and to the point. 1775. What is the difference between the highest and the second highest Number of teachers of Qatar?
Provide a succinct answer. 146. What is the difference between the highest and the lowest Number of teachers of Middle income?
Offer a very short reply. 2.69e+06. What is the difference between the highest and the lowest Number of teachers of Botswana?
Your response must be concise. 5317. What is the difference between the highest and the lowest Number of teachers of Myanmar?
Offer a terse response. 3.82e+04. What is the difference between the highest and the lowest Number of teachers of Qatar?
Keep it short and to the point. 792. 